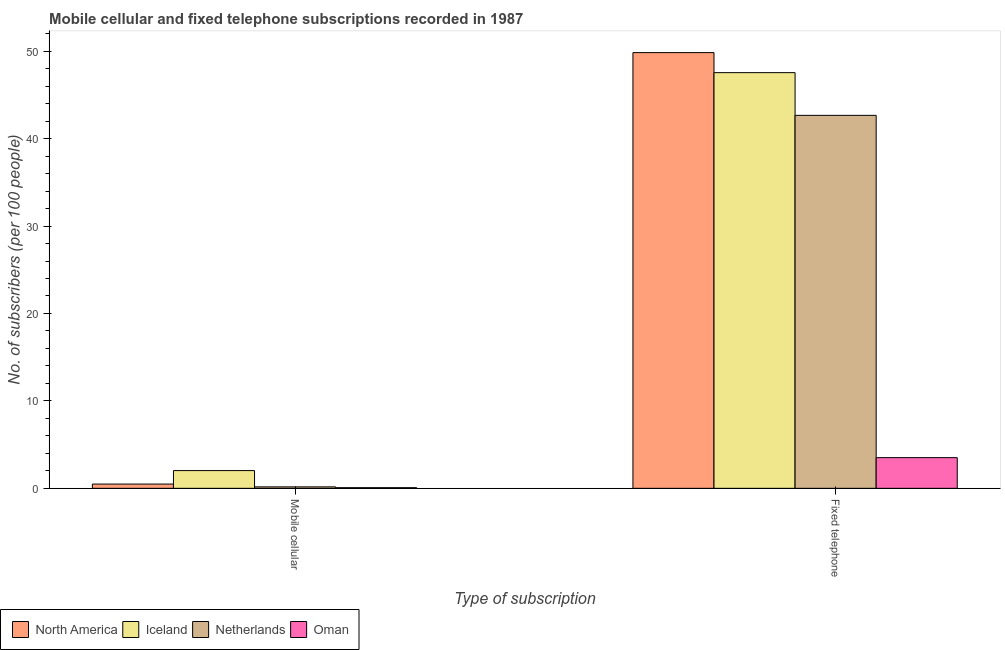Are the number of bars per tick equal to the number of legend labels?
Ensure brevity in your answer.  Yes. Are the number of bars on each tick of the X-axis equal?
Give a very brief answer. Yes. How many bars are there on the 2nd tick from the left?
Your answer should be very brief. 4. How many bars are there on the 1st tick from the right?
Provide a succinct answer. 4. What is the label of the 2nd group of bars from the left?
Provide a succinct answer. Fixed telephone. What is the number of fixed telephone subscribers in Netherlands?
Ensure brevity in your answer.  42.66. Across all countries, what is the maximum number of fixed telephone subscribers?
Offer a very short reply. 49.84. Across all countries, what is the minimum number of fixed telephone subscribers?
Offer a very short reply. 3.51. In which country was the number of mobile cellular subscribers minimum?
Give a very brief answer. Oman. What is the total number of mobile cellular subscribers in the graph?
Keep it short and to the point. 2.75. What is the difference between the number of fixed telephone subscribers in North America and that in Iceland?
Your answer should be very brief. 2.29. What is the difference between the number of mobile cellular subscribers in Iceland and the number of fixed telephone subscribers in Oman?
Give a very brief answer. -1.48. What is the average number of mobile cellular subscribers per country?
Offer a very short reply. 0.69. What is the difference between the number of fixed telephone subscribers and number of mobile cellular subscribers in Oman?
Ensure brevity in your answer.  3.44. What is the ratio of the number of fixed telephone subscribers in Iceland to that in Netherlands?
Your answer should be compact. 1.11. In how many countries, is the number of mobile cellular subscribers greater than the average number of mobile cellular subscribers taken over all countries?
Offer a very short reply. 1. What does the 4th bar from the left in Fixed telephone represents?
Keep it short and to the point. Oman. What does the 1st bar from the right in Fixed telephone represents?
Offer a very short reply. Oman. How many bars are there?
Ensure brevity in your answer.  8. Are all the bars in the graph horizontal?
Ensure brevity in your answer.  No. Are the values on the major ticks of Y-axis written in scientific E-notation?
Your answer should be compact. No. Does the graph contain any zero values?
Provide a succinct answer. No. Where does the legend appear in the graph?
Give a very brief answer. Bottom left. How many legend labels are there?
Make the answer very short. 4. What is the title of the graph?
Your answer should be compact. Mobile cellular and fixed telephone subscriptions recorded in 1987. What is the label or title of the X-axis?
Provide a succinct answer. Type of subscription. What is the label or title of the Y-axis?
Provide a short and direct response. No. of subscribers (per 100 people). What is the No. of subscribers (per 100 people) of North America in Mobile cellular?
Offer a terse response. 0.49. What is the No. of subscribers (per 100 people) of Iceland in Mobile cellular?
Provide a short and direct response. 2.03. What is the No. of subscribers (per 100 people) of Netherlands in Mobile cellular?
Offer a very short reply. 0.17. What is the No. of subscribers (per 100 people) in Oman in Mobile cellular?
Ensure brevity in your answer.  0.07. What is the No. of subscribers (per 100 people) in North America in Fixed telephone?
Make the answer very short. 49.84. What is the No. of subscribers (per 100 people) of Iceland in Fixed telephone?
Your answer should be compact. 47.54. What is the No. of subscribers (per 100 people) in Netherlands in Fixed telephone?
Your answer should be compact. 42.66. What is the No. of subscribers (per 100 people) of Oman in Fixed telephone?
Keep it short and to the point. 3.51. Across all Type of subscription, what is the maximum No. of subscribers (per 100 people) in North America?
Provide a short and direct response. 49.84. Across all Type of subscription, what is the maximum No. of subscribers (per 100 people) of Iceland?
Your response must be concise. 47.54. Across all Type of subscription, what is the maximum No. of subscribers (per 100 people) in Netherlands?
Provide a succinct answer. 42.66. Across all Type of subscription, what is the maximum No. of subscribers (per 100 people) in Oman?
Give a very brief answer. 3.51. Across all Type of subscription, what is the minimum No. of subscribers (per 100 people) of North America?
Your answer should be very brief. 0.49. Across all Type of subscription, what is the minimum No. of subscribers (per 100 people) of Iceland?
Give a very brief answer. 2.03. Across all Type of subscription, what is the minimum No. of subscribers (per 100 people) of Netherlands?
Offer a very short reply. 0.17. Across all Type of subscription, what is the minimum No. of subscribers (per 100 people) of Oman?
Your response must be concise. 0.07. What is the total No. of subscribers (per 100 people) in North America in the graph?
Your answer should be very brief. 50.32. What is the total No. of subscribers (per 100 people) in Iceland in the graph?
Offer a very short reply. 49.57. What is the total No. of subscribers (per 100 people) in Netherlands in the graph?
Your response must be concise. 42.83. What is the total No. of subscribers (per 100 people) of Oman in the graph?
Make the answer very short. 3.58. What is the difference between the No. of subscribers (per 100 people) in North America in Mobile cellular and that in Fixed telephone?
Your answer should be very brief. -49.35. What is the difference between the No. of subscribers (per 100 people) of Iceland in Mobile cellular and that in Fixed telephone?
Make the answer very short. -45.52. What is the difference between the No. of subscribers (per 100 people) in Netherlands in Mobile cellular and that in Fixed telephone?
Keep it short and to the point. -42.49. What is the difference between the No. of subscribers (per 100 people) of Oman in Mobile cellular and that in Fixed telephone?
Make the answer very short. -3.44. What is the difference between the No. of subscribers (per 100 people) of North America in Mobile cellular and the No. of subscribers (per 100 people) of Iceland in Fixed telephone?
Ensure brevity in your answer.  -47.06. What is the difference between the No. of subscribers (per 100 people) of North America in Mobile cellular and the No. of subscribers (per 100 people) of Netherlands in Fixed telephone?
Your answer should be very brief. -42.17. What is the difference between the No. of subscribers (per 100 people) of North America in Mobile cellular and the No. of subscribers (per 100 people) of Oman in Fixed telephone?
Your response must be concise. -3.02. What is the difference between the No. of subscribers (per 100 people) of Iceland in Mobile cellular and the No. of subscribers (per 100 people) of Netherlands in Fixed telephone?
Keep it short and to the point. -40.63. What is the difference between the No. of subscribers (per 100 people) in Iceland in Mobile cellular and the No. of subscribers (per 100 people) in Oman in Fixed telephone?
Ensure brevity in your answer.  -1.48. What is the difference between the No. of subscribers (per 100 people) of Netherlands in Mobile cellular and the No. of subscribers (per 100 people) of Oman in Fixed telephone?
Your answer should be compact. -3.34. What is the average No. of subscribers (per 100 people) of North America per Type of subscription?
Make the answer very short. 25.16. What is the average No. of subscribers (per 100 people) of Iceland per Type of subscription?
Offer a terse response. 24.79. What is the average No. of subscribers (per 100 people) of Netherlands per Type of subscription?
Offer a terse response. 21.41. What is the average No. of subscribers (per 100 people) of Oman per Type of subscription?
Keep it short and to the point. 1.79. What is the difference between the No. of subscribers (per 100 people) of North America and No. of subscribers (per 100 people) of Iceland in Mobile cellular?
Your answer should be compact. -1.54. What is the difference between the No. of subscribers (per 100 people) in North America and No. of subscribers (per 100 people) in Netherlands in Mobile cellular?
Your answer should be compact. 0.32. What is the difference between the No. of subscribers (per 100 people) of North America and No. of subscribers (per 100 people) of Oman in Mobile cellular?
Give a very brief answer. 0.41. What is the difference between the No. of subscribers (per 100 people) in Iceland and No. of subscribers (per 100 people) in Netherlands in Mobile cellular?
Your response must be concise. 1.86. What is the difference between the No. of subscribers (per 100 people) in Iceland and No. of subscribers (per 100 people) in Oman in Mobile cellular?
Provide a succinct answer. 1.96. What is the difference between the No. of subscribers (per 100 people) in Netherlands and No. of subscribers (per 100 people) in Oman in Mobile cellular?
Provide a succinct answer. 0.09. What is the difference between the No. of subscribers (per 100 people) of North America and No. of subscribers (per 100 people) of Iceland in Fixed telephone?
Offer a terse response. 2.29. What is the difference between the No. of subscribers (per 100 people) in North America and No. of subscribers (per 100 people) in Netherlands in Fixed telephone?
Make the answer very short. 7.18. What is the difference between the No. of subscribers (per 100 people) in North America and No. of subscribers (per 100 people) in Oman in Fixed telephone?
Ensure brevity in your answer.  46.33. What is the difference between the No. of subscribers (per 100 people) in Iceland and No. of subscribers (per 100 people) in Netherlands in Fixed telephone?
Give a very brief answer. 4.88. What is the difference between the No. of subscribers (per 100 people) in Iceland and No. of subscribers (per 100 people) in Oman in Fixed telephone?
Give a very brief answer. 44.04. What is the difference between the No. of subscribers (per 100 people) of Netherlands and No. of subscribers (per 100 people) of Oman in Fixed telephone?
Provide a succinct answer. 39.15. What is the ratio of the No. of subscribers (per 100 people) of North America in Mobile cellular to that in Fixed telephone?
Make the answer very short. 0.01. What is the ratio of the No. of subscribers (per 100 people) in Iceland in Mobile cellular to that in Fixed telephone?
Offer a very short reply. 0.04. What is the ratio of the No. of subscribers (per 100 people) of Netherlands in Mobile cellular to that in Fixed telephone?
Your response must be concise. 0. What is the ratio of the No. of subscribers (per 100 people) of Oman in Mobile cellular to that in Fixed telephone?
Keep it short and to the point. 0.02. What is the difference between the highest and the second highest No. of subscribers (per 100 people) of North America?
Your answer should be compact. 49.35. What is the difference between the highest and the second highest No. of subscribers (per 100 people) of Iceland?
Ensure brevity in your answer.  45.52. What is the difference between the highest and the second highest No. of subscribers (per 100 people) of Netherlands?
Your response must be concise. 42.49. What is the difference between the highest and the second highest No. of subscribers (per 100 people) in Oman?
Your answer should be compact. 3.44. What is the difference between the highest and the lowest No. of subscribers (per 100 people) of North America?
Keep it short and to the point. 49.35. What is the difference between the highest and the lowest No. of subscribers (per 100 people) of Iceland?
Make the answer very short. 45.52. What is the difference between the highest and the lowest No. of subscribers (per 100 people) of Netherlands?
Provide a short and direct response. 42.49. What is the difference between the highest and the lowest No. of subscribers (per 100 people) in Oman?
Offer a terse response. 3.44. 